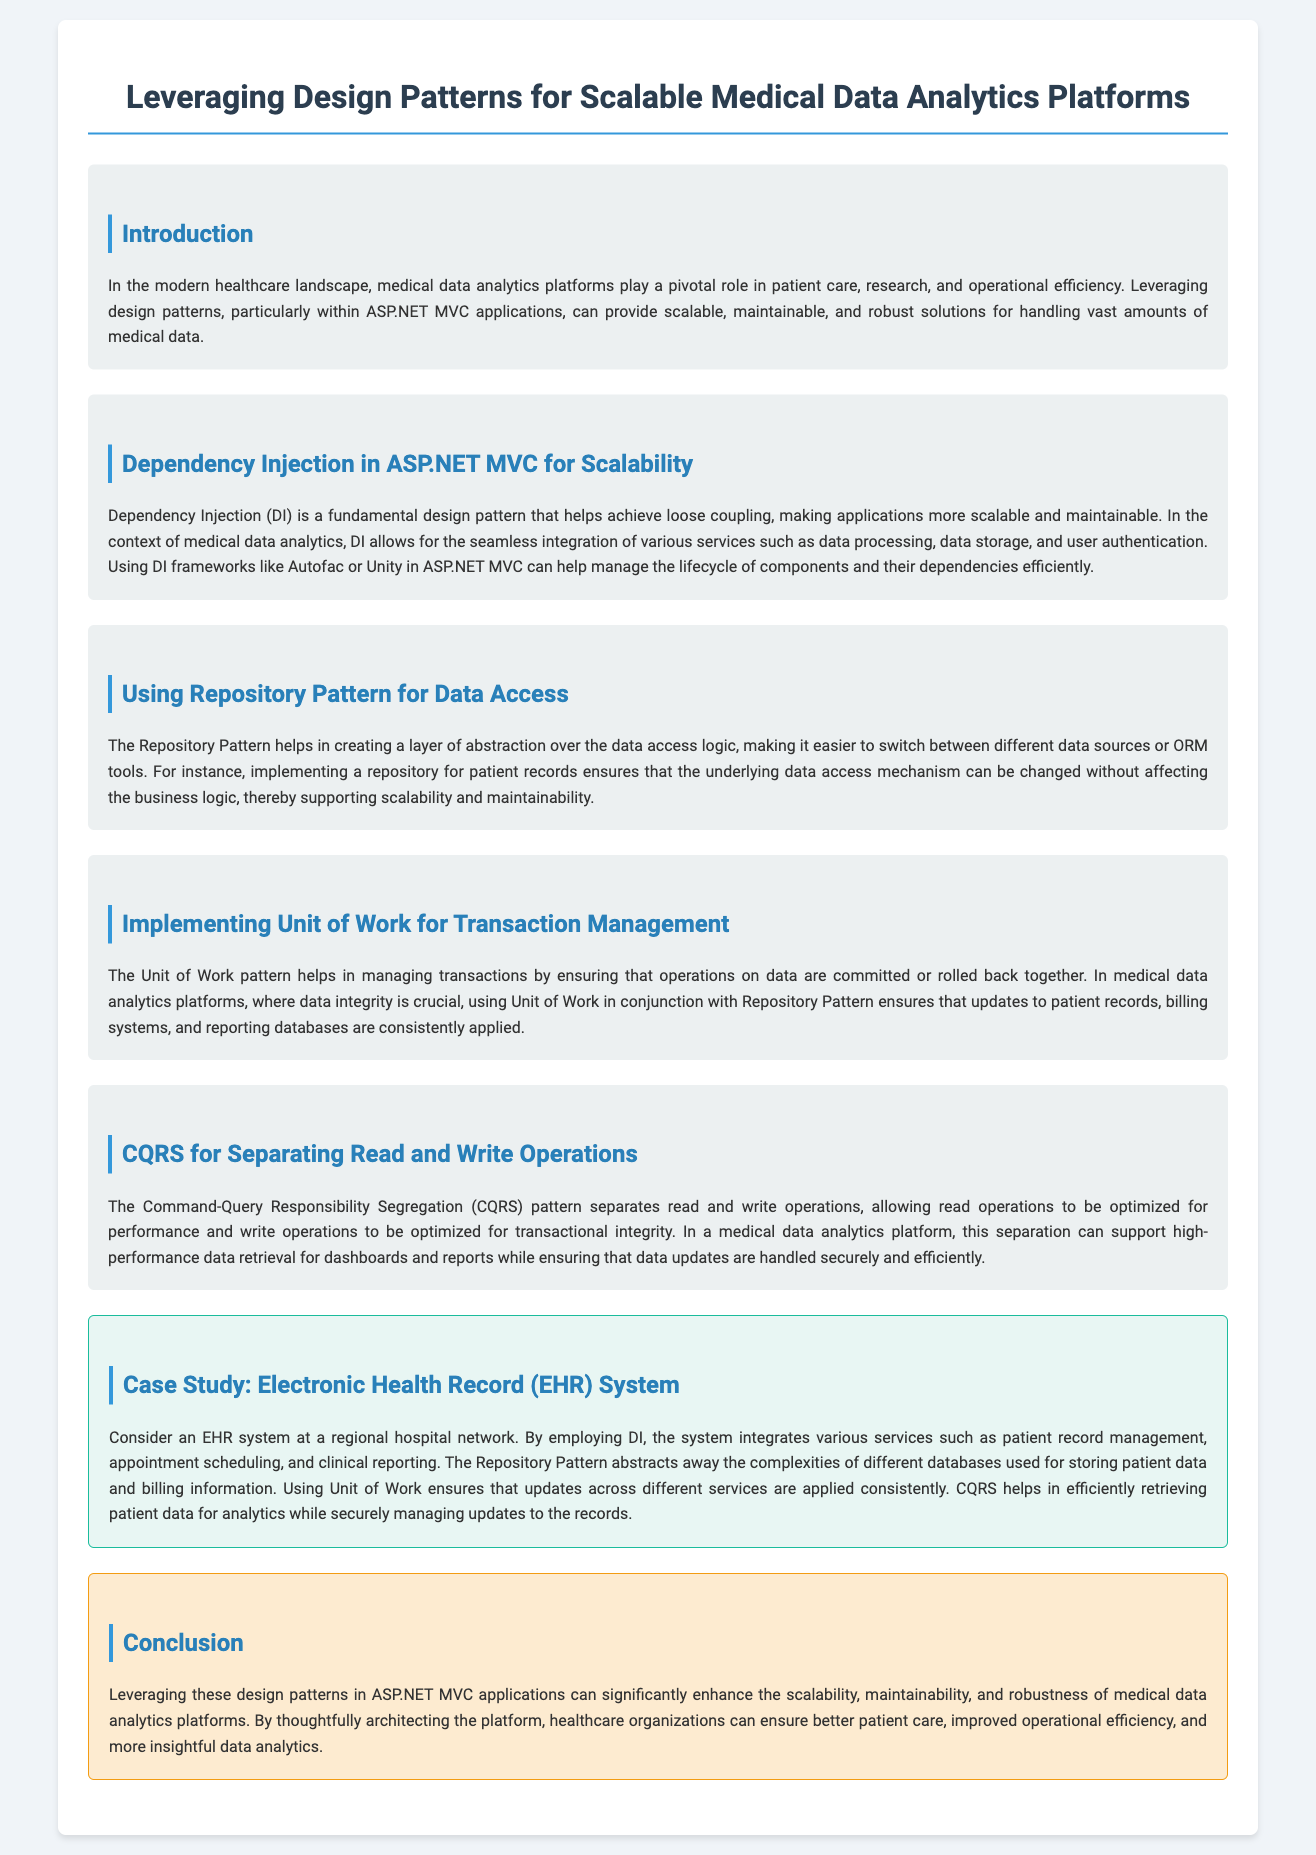What is the title of the document? The title is stated in the <title> element of the document, which is "Leveraging Design Patterns for Scalable Medical Data Analytics Platforms."
Answer: Leveraging Design Patterns for Scalable Medical Data Analytics Platforms What is the fundamental design pattern discussed for scalability? The document highlights Dependency Injection as a fundamental design pattern in the context of scalability.
Answer: Dependency Injection What pattern helps create a layer of abstraction over data access? The document mentions the Repository Pattern as a method to achieve this abstraction in data access logic.
Answer: Repository Pattern What is the purpose of the Unit of Work pattern in the document? The document explains that the Unit of Work pattern is used for managing transactions and ensuring data integrity.
Answer: Managing transactions What does CQRS stand for? The document abbreviates this pattern as CQRS, which refers to Command-Query Responsibility Segregation.
Answer: CQRS In the case study, what system is used as an example? The case study in the document discusses an Electronic Health Record system to illustrate the patterns.
Answer: Electronic Health Record (EHR) System What is the color code for the background in the conclusion section? The document specifies a background color for the conclusion section, which is described as "#fdebd0."
Answer: #fdebd0 Which design pattern ensures consistent updates across different services? The document indicates that the Unit of Work pattern ensures that updates across various services are applied consistently.
Answer: Unit of Work What is the focus of the introduction section? The introduction emphasizes the role of medical data analytics platforms in patient care, research, and operational efficiency.
Answer: Patient care, research, and operational efficiency 